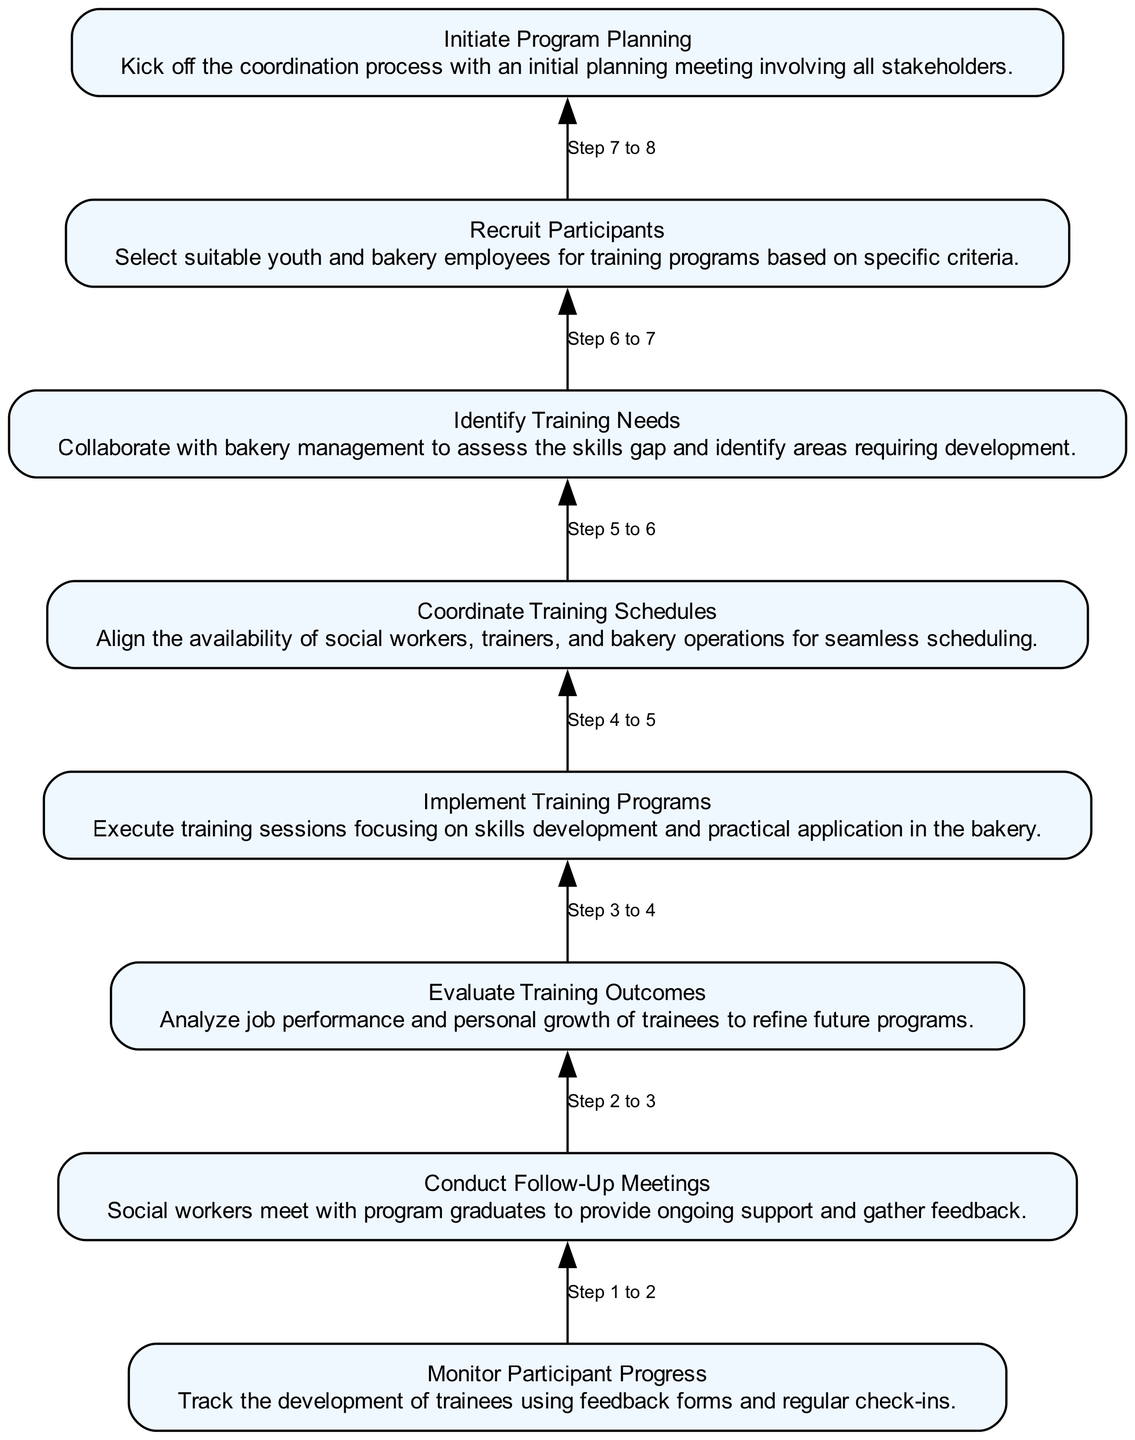What is the first step in the workflow? The diagram shows that the first step is "Initiate Program Planning". It is the bottom node that starts the flow of the process.
Answer: Initiate Program Planning How many total steps are there in the workflow? The workflow includes 8 distinct steps, counting from the bottom to the top of the flowchart.
Answer: 8 What is the last step in the workflow? The last step, positioned at the top of the flowchart, is "Monitor Participant Progress". This indicates the final action taken after all prior steps.
Answer: Monitor Participant Progress Which step involves collaboration with bakery management? The step "Identify Training Needs" involves collaboration with bakery management to assess skills gaps. This step is crucial for understanding what training is necessary.
Answer: Identify Training Needs What is the relationship between "Recruit Participants" and "Conduct Follow-Up Meetings"? "Recruit Participants" leads directly to the next step "Initiate Program Planning", while "Conduct Follow-Up Meetings" occurs after "Implement Training Programs". Their relation is part of different phases in the workflow.
Answer: No direct relation How does "Evaluate Training Outcomes" impact future training? "Evaluate Training Outcomes" directly influences the refinement of future programs by analyzing job performance and personal growth of trainees, providing feedback for improvement.
Answer: Refines future programs What is the purpose of "Coordinate Training Schedules"? The purpose of "Coordinate Training Schedules" is to align the availability of social workers, trainers, and bakery operations. This ensures that the training program runs smoothly and effectively.
Answer: Aligns availability Which step follows "Implement Training Programs"? Following "Implement Training Programs", the next step is "Conduct Follow-Up Meetings". This indicates a progression from training delivery to support and feedback.
Answer: Conduct Follow-Up Meetings 